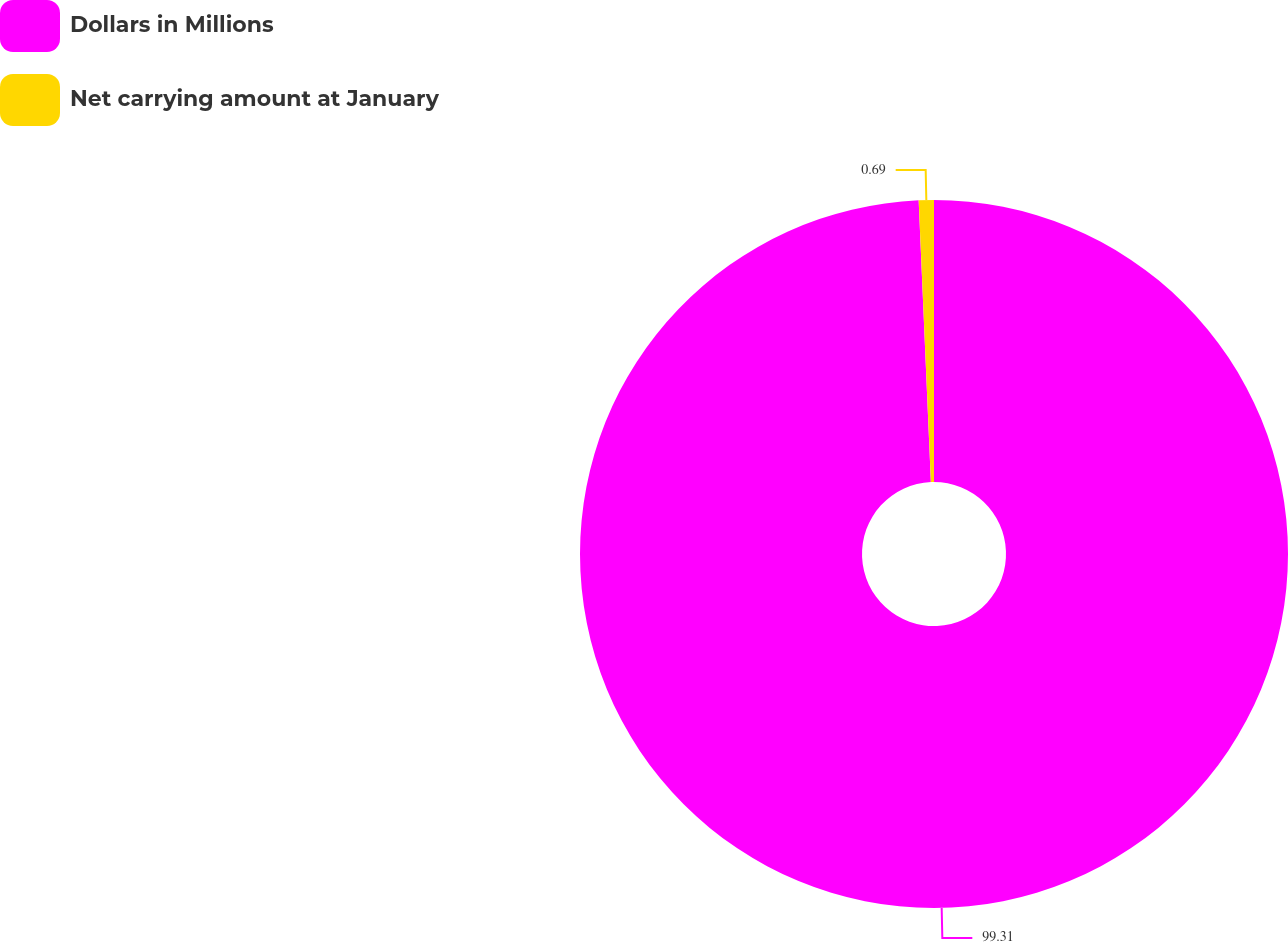<chart> <loc_0><loc_0><loc_500><loc_500><pie_chart><fcel>Dollars in Millions<fcel>Net carrying amount at January<nl><fcel>99.31%<fcel>0.69%<nl></chart> 